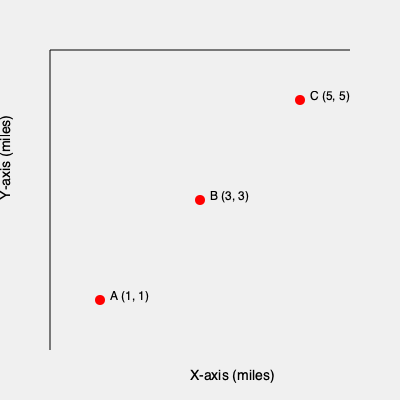A young book enthusiast is planning to attend three book signings in different locations across the city. The locations are plotted on a coordinate system where each unit represents one mile. Book signing A is at (1, 1), B is at (3, 3), and C is at (5, 5). If the enthusiast starts at point A and wants to visit all locations in alphabetical order (A → B → C), what is the total distance traveled in miles? To solve this problem, we need to calculate the distances between each pair of points and sum them up. We can use the distance formula between two points: $d = \sqrt{(x_2-x_1)^2 + (y_2-y_1)^2}$

Step 1: Calculate the distance from A to B
$d_{AB} = \sqrt{(3-1)^2 + (3-1)^2} = \sqrt{4 + 4} = \sqrt{8} = 2\sqrt{2}$ miles

Step 2: Calculate the distance from B to C
$d_{BC} = \sqrt{(5-3)^2 + (5-3)^2} = \sqrt{4 + 4} = \sqrt{8} = 2\sqrt{2}$ miles

Step 3: Sum up the total distance
Total distance = $d_{AB} + d_{BC} = 2\sqrt{2} + 2\sqrt{2} = 4\sqrt{2}$ miles

Therefore, the total distance traveled is $4\sqrt{2}$ miles.
Answer: $4\sqrt{2}$ miles 